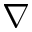<formula> <loc_0><loc_0><loc_500><loc_500>\nabla</formula> 